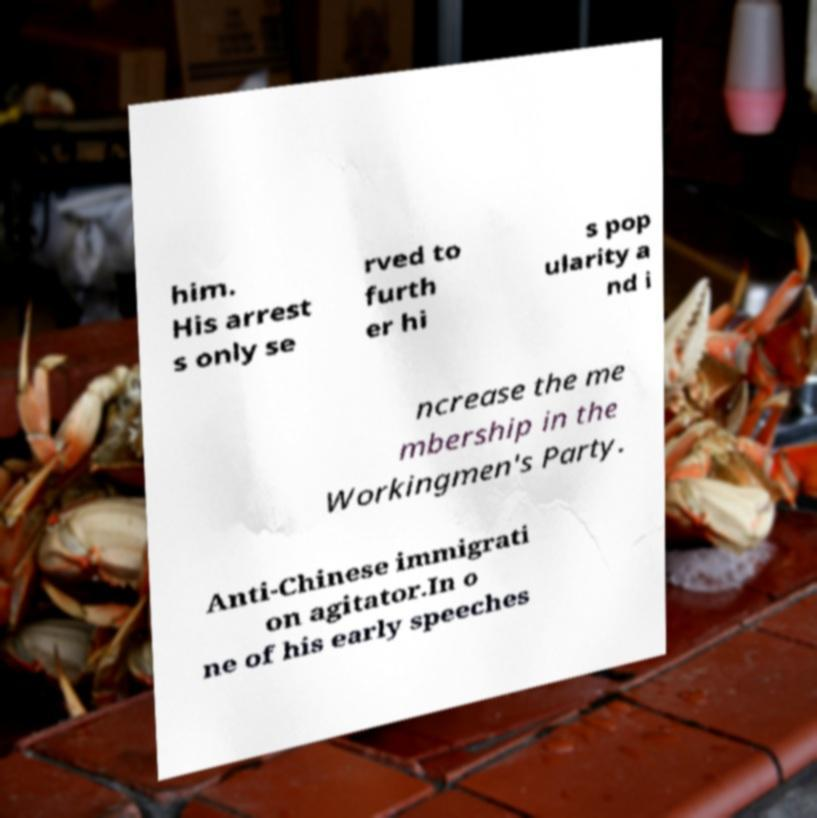What messages or text are displayed in this image? I need them in a readable, typed format. him. His arrest s only se rved to furth er hi s pop ularity a nd i ncrease the me mbership in the Workingmen's Party. Anti-Chinese immigrati on agitator.In o ne of his early speeches 